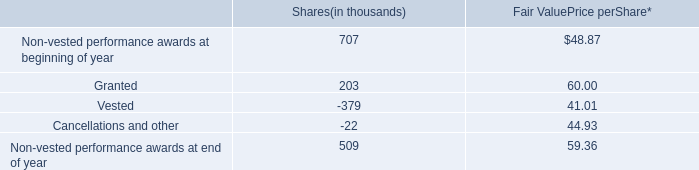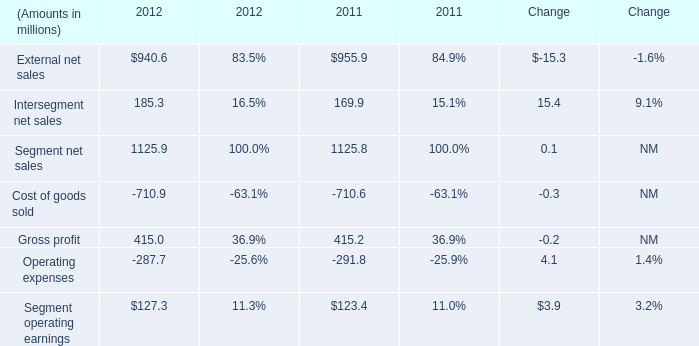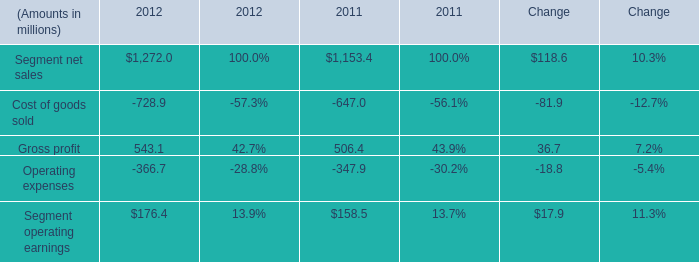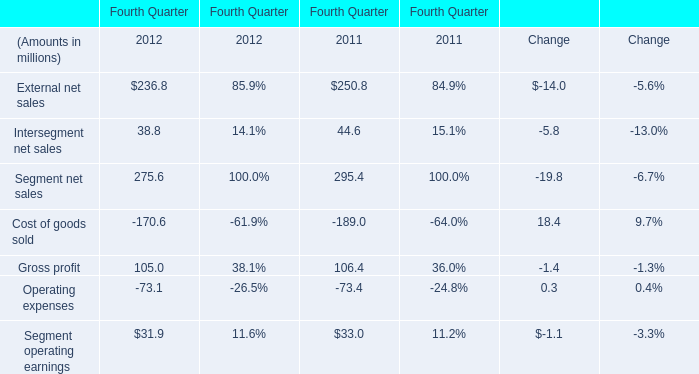in 2012 what was the percent change in the number of shares that was not vested 
Computations: ((509 - 707) - 707)
Answer: -905.0. 